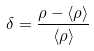Convert formula to latex. <formula><loc_0><loc_0><loc_500><loc_500>\delta = \frac { \rho - \langle \rho \rangle } { \langle \rho \rangle }</formula> 